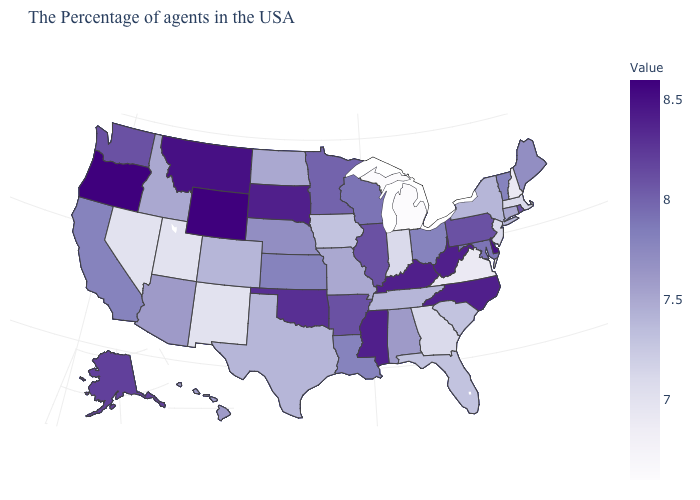Is the legend a continuous bar?
Concise answer only. Yes. Among the states that border Idaho , which have the lowest value?
Concise answer only. Utah, Nevada. Among the states that border Wyoming , which have the lowest value?
Write a very short answer. Utah. Among the states that border New York , does Pennsylvania have the highest value?
Answer briefly. Yes. Is the legend a continuous bar?
Write a very short answer. Yes. Does Delaware have the highest value in the South?
Concise answer only. Yes. 